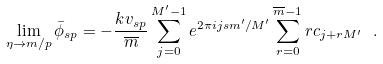<formula> <loc_0><loc_0><loc_500><loc_500>\lim _ { \eta \rightarrow m / p } { \bar { \phi } } _ { s p } = - \frac { k v _ { s p } } { \overline { m } } \sum _ { j = 0 } ^ { M ^ { \prime } - 1 } e ^ { 2 \pi i j s m ^ { \prime } / M ^ { \prime } } \sum _ { r = 0 } ^ { \overline { m } - 1 } r c _ { j + r M ^ { \prime } } \ .</formula> 